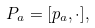Convert formula to latex. <formula><loc_0><loc_0><loc_500><loc_500>P _ { a } = [ p _ { a } , \cdot ] ,</formula> 